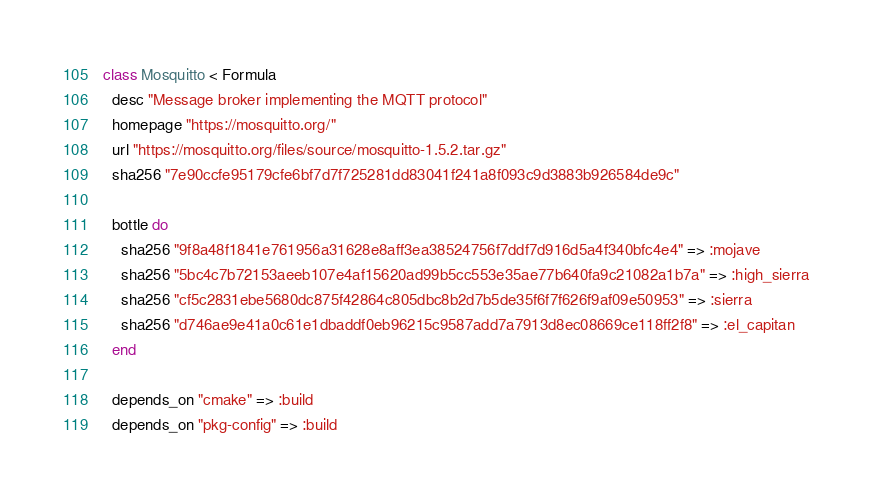<code> <loc_0><loc_0><loc_500><loc_500><_Ruby_>class Mosquitto < Formula
  desc "Message broker implementing the MQTT protocol"
  homepage "https://mosquitto.org/"
  url "https://mosquitto.org/files/source/mosquitto-1.5.2.tar.gz"
  sha256 "7e90ccfe95179cfe6bf7d7f725281dd83041f241a8f093c9d3883b926584de9c"

  bottle do
    sha256 "9f8a48f1841e761956a31628e8aff3ea38524756f7ddf7d916d5a4f340bfc4e4" => :mojave
    sha256 "5bc4c7b72153aeeb107e4af15620ad99b5cc553e35ae77b640fa9c21082a1b7a" => :high_sierra
    sha256 "cf5c2831ebe5680dc875f42864c805dbc8b2d7b5de35f6f7f626f9af09e50953" => :sierra
    sha256 "d746ae9e41a0c61e1dbaddf0eb96215c9587add7a7913d8ec08669ce118ff2f8" => :el_capitan
  end

  depends_on "cmake" => :build
  depends_on "pkg-config" => :build</code> 